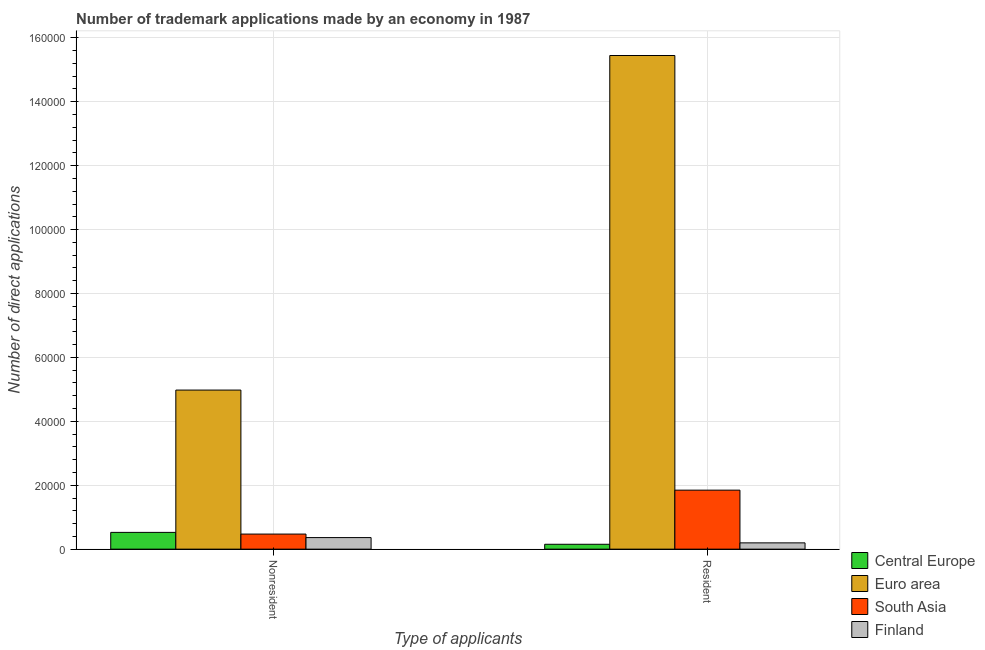How many different coloured bars are there?
Provide a succinct answer. 4. How many groups of bars are there?
Provide a succinct answer. 2. Are the number of bars per tick equal to the number of legend labels?
Offer a very short reply. Yes. Are the number of bars on each tick of the X-axis equal?
Ensure brevity in your answer.  Yes. How many bars are there on the 1st tick from the left?
Your response must be concise. 4. How many bars are there on the 1st tick from the right?
Keep it short and to the point. 4. What is the label of the 1st group of bars from the left?
Make the answer very short. Nonresident. What is the number of trademark applications made by residents in Central Europe?
Provide a succinct answer. 1528. Across all countries, what is the maximum number of trademark applications made by residents?
Make the answer very short. 1.54e+05. Across all countries, what is the minimum number of trademark applications made by residents?
Keep it short and to the point. 1528. In which country was the number of trademark applications made by non residents maximum?
Give a very brief answer. Euro area. In which country was the number of trademark applications made by residents minimum?
Your response must be concise. Central Europe. What is the total number of trademark applications made by non residents in the graph?
Your response must be concise. 6.34e+04. What is the difference between the number of trademark applications made by residents in Central Europe and that in South Asia?
Make the answer very short. -1.69e+04. What is the difference between the number of trademark applications made by residents in Finland and the number of trademark applications made by non residents in Central Europe?
Your answer should be compact. -3283. What is the average number of trademark applications made by non residents per country?
Ensure brevity in your answer.  1.58e+04. What is the difference between the number of trademark applications made by non residents and number of trademark applications made by residents in Euro area?
Provide a short and direct response. -1.05e+05. In how many countries, is the number of trademark applications made by residents greater than 120000 ?
Give a very brief answer. 1. What is the ratio of the number of trademark applications made by non residents in Central Europe to that in South Asia?
Provide a succinct answer. 1.11. In how many countries, is the number of trademark applications made by non residents greater than the average number of trademark applications made by non residents taken over all countries?
Your answer should be very brief. 1. What does the 2nd bar from the right in Nonresident represents?
Your answer should be compact. South Asia. How many bars are there?
Make the answer very short. 8. Are all the bars in the graph horizontal?
Make the answer very short. No. How many countries are there in the graph?
Provide a succinct answer. 4. How many legend labels are there?
Offer a terse response. 4. What is the title of the graph?
Give a very brief answer. Number of trademark applications made by an economy in 1987. What is the label or title of the X-axis?
Offer a terse response. Type of applicants. What is the label or title of the Y-axis?
Provide a short and direct response. Number of direct applications. What is the Number of direct applications of Central Europe in Nonresident?
Provide a succinct answer. 5247. What is the Number of direct applications of Euro area in Nonresident?
Provide a short and direct response. 4.98e+04. What is the Number of direct applications in South Asia in Nonresident?
Offer a terse response. 4717. What is the Number of direct applications in Finland in Nonresident?
Offer a very short reply. 3617. What is the Number of direct applications of Central Europe in Resident?
Your response must be concise. 1528. What is the Number of direct applications in Euro area in Resident?
Provide a short and direct response. 1.54e+05. What is the Number of direct applications in South Asia in Resident?
Offer a terse response. 1.85e+04. What is the Number of direct applications of Finland in Resident?
Offer a terse response. 1964. Across all Type of applicants, what is the maximum Number of direct applications of Central Europe?
Give a very brief answer. 5247. Across all Type of applicants, what is the maximum Number of direct applications in Euro area?
Offer a terse response. 1.54e+05. Across all Type of applicants, what is the maximum Number of direct applications in South Asia?
Provide a short and direct response. 1.85e+04. Across all Type of applicants, what is the maximum Number of direct applications in Finland?
Ensure brevity in your answer.  3617. Across all Type of applicants, what is the minimum Number of direct applications in Central Europe?
Offer a terse response. 1528. Across all Type of applicants, what is the minimum Number of direct applications in Euro area?
Offer a very short reply. 4.98e+04. Across all Type of applicants, what is the minimum Number of direct applications in South Asia?
Your answer should be compact. 4717. Across all Type of applicants, what is the minimum Number of direct applications in Finland?
Provide a short and direct response. 1964. What is the total Number of direct applications in Central Europe in the graph?
Offer a terse response. 6775. What is the total Number of direct applications in Euro area in the graph?
Keep it short and to the point. 2.04e+05. What is the total Number of direct applications of South Asia in the graph?
Make the answer very short. 2.32e+04. What is the total Number of direct applications of Finland in the graph?
Your answer should be very brief. 5581. What is the difference between the Number of direct applications in Central Europe in Nonresident and that in Resident?
Provide a short and direct response. 3719. What is the difference between the Number of direct applications in Euro area in Nonresident and that in Resident?
Your answer should be very brief. -1.05e+05. What is the difference between the Number of direct applications of South Asia in Nonresident and that in Resident?
Offer a very short reply. -1.37e+04. What is the difference between the Number of direct applications of Finland in Nonresident and that in Resident?
Provide a short and direct response. 1653. What is the difference between the Number of direct applications of Central Europe in Nonresident and the Number of direct applications of Euro area in Resident?
Your answer should be very brief. -1.49e+05. What is the difference between the Number of direct applications in Central Europe in Nonresident and the Number of direct applications in South Asia in Resident?
Your answer should be very brief. -1.32e+04. What is the difference between the Number of direct applications of Central Europe in Nonresident and the Number of direct applications of Finland in Resident?
Your answer should be very brief. 3283. What is the difference between the Number of direct applications in Euro area in Nonresident and the Number of direct applications in South Asia in Resident?
Offer a very short reply. 3.13e+04. What is the difference between the Number of direct applications of Euro area in Nonresident and the Number of direct applications of Finland in Resident?
Offer a terse response. 4.78e+04. What is the difference between the Number of direct applications of South Asia in Nonresident and the Number of direct applications of Finland in Resident?
Provide a short and direct response. 2753. What is the average Number of direct applications in Central Europe per Type of applicants?
Provide a short and direct response. 3387.5. What is the average Number of direct applications of Euro area per Type of applicants?
Ensure brevity in your answer.  1.02e+05. What is the average Number of direct applications of South Asia per Type of applicants?
Keep it short and to the point. 1.16e+04. What is the average Number of direct applications in Finland per Type of applicants?
Provide a short and direct response. 2790.5. What is the difference between the Number of direct applications of Central Europe and Number of direct applications of Euro area in Nonresident?
Provide a short and direct response. -4.45e+04. What is the difference between the Number of direct applications of Central Europe and Number of direct applications of South Asia in Nonresident?
Offer a terse response. 530. What is the difference between the Number of direct applications of Central Europe and Number of direct applications of Finland in Nonresident?
Your response must be concise. 1630. What is the difference between the Number of direct applications in Euro area and Number of direct applications in South Asia in Nonresident?
Give a very brief answer. 4.51e+04. What is the difference between the Number of direct applications in Euro area and Number of direct applications in Finland in Nonresident?
Keep it short and to the point. 4.62e+04. What is the difference between the Number of direct applications in South Asia and Number of direct applications in Finland in Nonresident?
Offer a very short reply. 1100. What is the difference between the Number of direct applications in Central Europe and Number of direct applications in Euro area in Resident?
Provide a short and direct response. -1.53e+05. What is the difference between the Number of direct applications of Central Europe and Number of direct applications of South Asia in Resident?
Provide a short and direct response. -1.69e+04. What is the difference between the Number of direct applications in Central Europe and Number of direct applications in Finland in Resident?
Ensure brevity in your answer.  -436. What is the difference between the Number of direct applications in Euro area and Number of direct applications in South Asia in Resident?
Give a very brief answer. 1.36e+05. What is the difference between the Number of direct applications in Euro area and Number of direct applications in Finland in Resident?
Make the answer very short. 1.53e+05. What is the difference between the Number of direct applications in South Asia and Number of direct applications in Finland in Resident?
Offer a terse response. 1.65e+04. What is the ratio of the Number of direct applications in Central Europe in Nonresident to that in Resident?
Give a very brief answer. 3.43. What is the ratio of the Number of direct applications in Euro area in Nonresident to that in Resident?
Offer a terse response. 0.32. What is the ratio of the Number of direct applications of South Asia in Nonresident to that in Resident?
Offer a terse response. 0.26. What is the ratio of the Number of direct applications in Finland in Nonresident to that in Resident?
Ensure brevity in your answer.  1.84. What is the difference between the highest and the second highest Number of direct applications of Central Europe?
Your answer should be very brief. 3719. What is the difference between the highest and the second highest Number of direct applications in Euro area?
Offer a terse response. 1.05e+05. What is the difference between the highest and the second highest Number of direct applications in South Asia?
Ensure brevity in your answer.  1.37e+04. What is the difference between the highest and the second highest Number of direct applications in Finland?
Provide a short and direct response. 1653. What is the difference between the highest and the lowest Number of direct applications in Central Europe?
Give a very brief answer. 3719. What is the difference between the highest and the lowest Number of direct applications in Euro area?
Give a very brief answer. 1.05e+05. What is the difference between the highest and the lowest Number of direct applications of South Asia?
Provide a succinct answer. 1.37e+04. What is the difference between the highest and the lowest Number of direct applications of Finland?
Your response must be concise. 1653. 